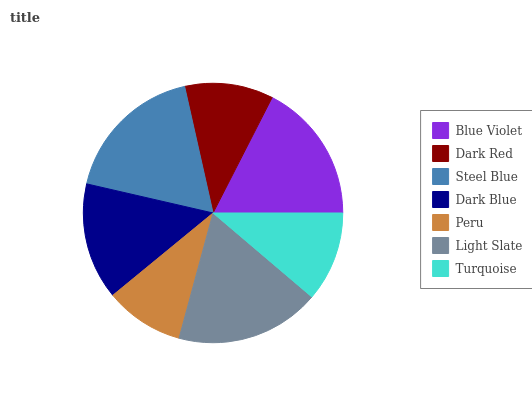Is Peru the minimum?
Answer yes or no. Yes. Is Light Slate the maximum?
Answer yes or no. Yes. Is Dark Red the minimum?
Answer yes or no. No. Is Dark Red the maximum?
Answer yes or no. No. Is Blue Violet greater than Dark Red?
Answer yes or no. Yes. Is Dark Red less than Blue Violet?
Answer yes or no. Yes. Is Dark Red greater than Blue Violet?
Answer yes or no. No. Is Blue Violet less than Dark Red?
Answer yes or no. No. Is Dark Blue the high median?
Answer yes or no. Yes. Is Dark Blue the low median?
Answer yes or no. Yes. Is Steel Blue the high median?
Answer yes or no. No. Is Light Slate the low median?
Answer yes or no. No. 